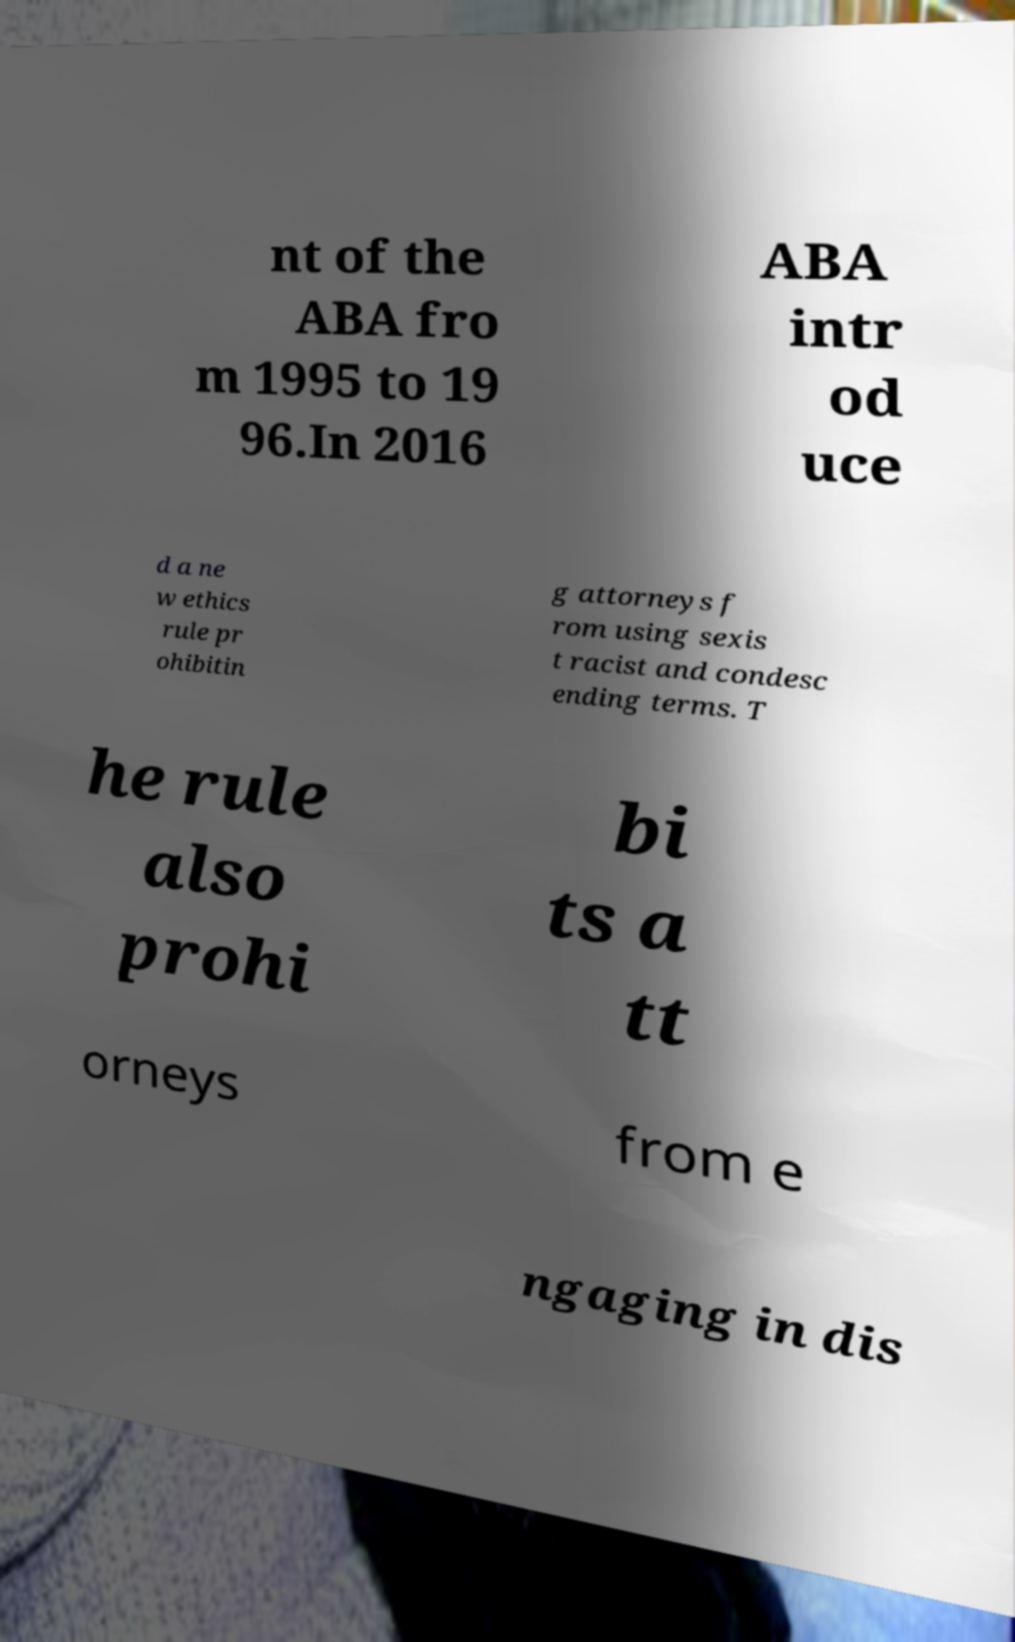There's text embedded in this image that I need extracted. Can you transcribe it verbatim? nt of the ABA fro m 1995 to 19 96.In 2016 ABA intr od uce d a ne w ethics rule pr ohibitin g attorneys f rom using sexis t racist and condesc ending terms. T he rule also prohi bi ts a tt orneys from e ngaging in dis 